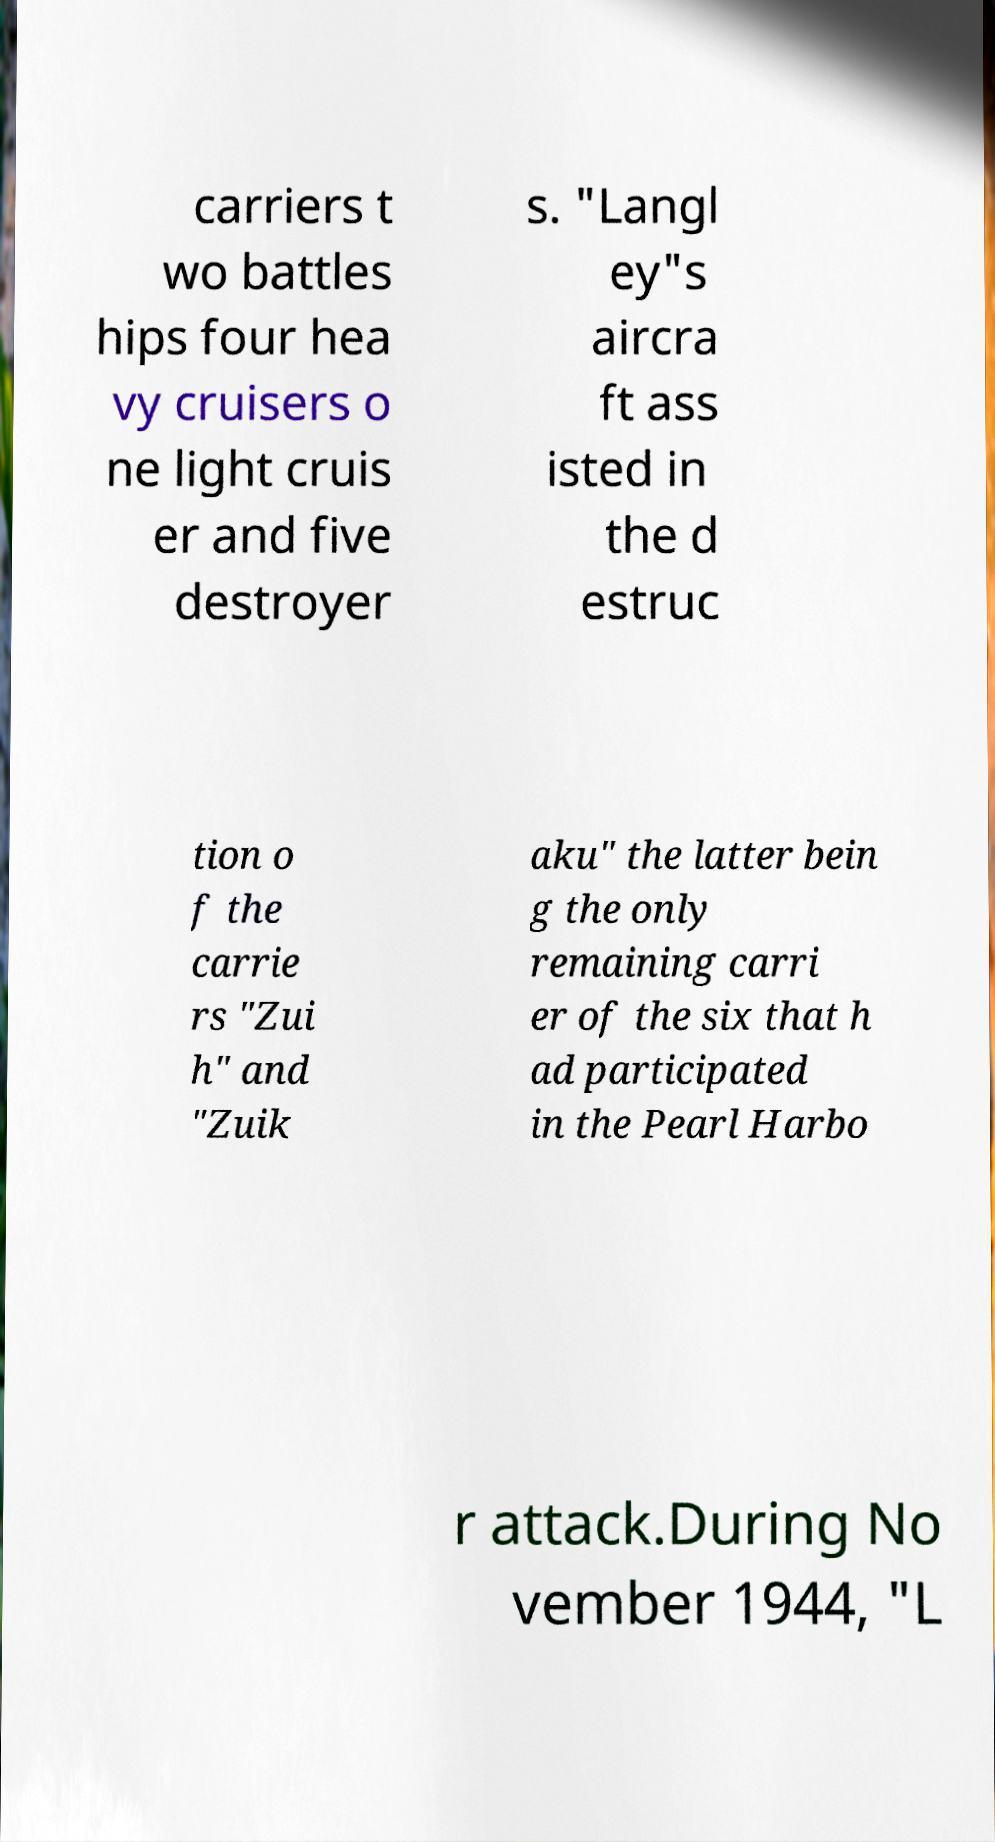Please identify and transcribe the text found in this image. carriers t wo battles hips four hea vy cruisers o ne light cruis er and five destroyer s. "Langl ey"s aircra ft ass isted in the d estruc tion o f the carrie rs "Zui h" and "Zuik aku" the latter bein g the only remaining carri er of the six that h ad participated in the Pearl Harbo r attack.During No vember 1944, "L 